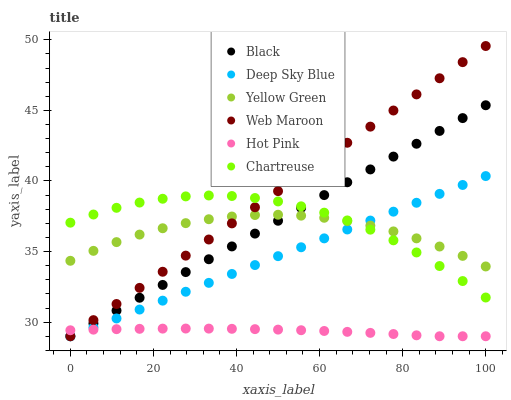Does Hot Pink have the minimum area under the curve?
Answer yes or no. Yes. Does Web Maroon have the maximum area under the curve?
Answer yes or no. Yes. Does Web Maroon have the minimum area under the curve?
Answer yes or no. No. Does Hot Pink have the maximum area under the curve?
Answer yes or no. No. Is Web Maroon the smoothest?
Answer yes or no. Yes. Is Chartreuse the roughest?
Answer yes or no. Yes. Is Hot Pink the smoothest?
Answer yes or no. No. Is Hot Pink the roughest?
Answer yes or no. No. Does Hot Pink have the lowest value?
Answer yes or no. Yes. Does Chartreuse have the lowest value?
Answer yes or no. No. Does Web Maroon have the highest value?
Answer yes or no. Yes. Does Hot Pink have the highest value?
Answer yes or no. No. Is Hot Pink less than Yellow Green?
Answer yes or no. Yes. Is Yellow Green greater than Hot Pink?
Answer yes or no. Yes. Does Deep Sky Blue intersect Black?
Answer yes or no. Yes. Is Deep Sky Blue less than Black?
Answer yes or no. No. Is Deep Sky Blue greater than Black?
Answer yes or no. No. Does Hot Pink intersect Yellow Green?
Answer yes or no. No. 